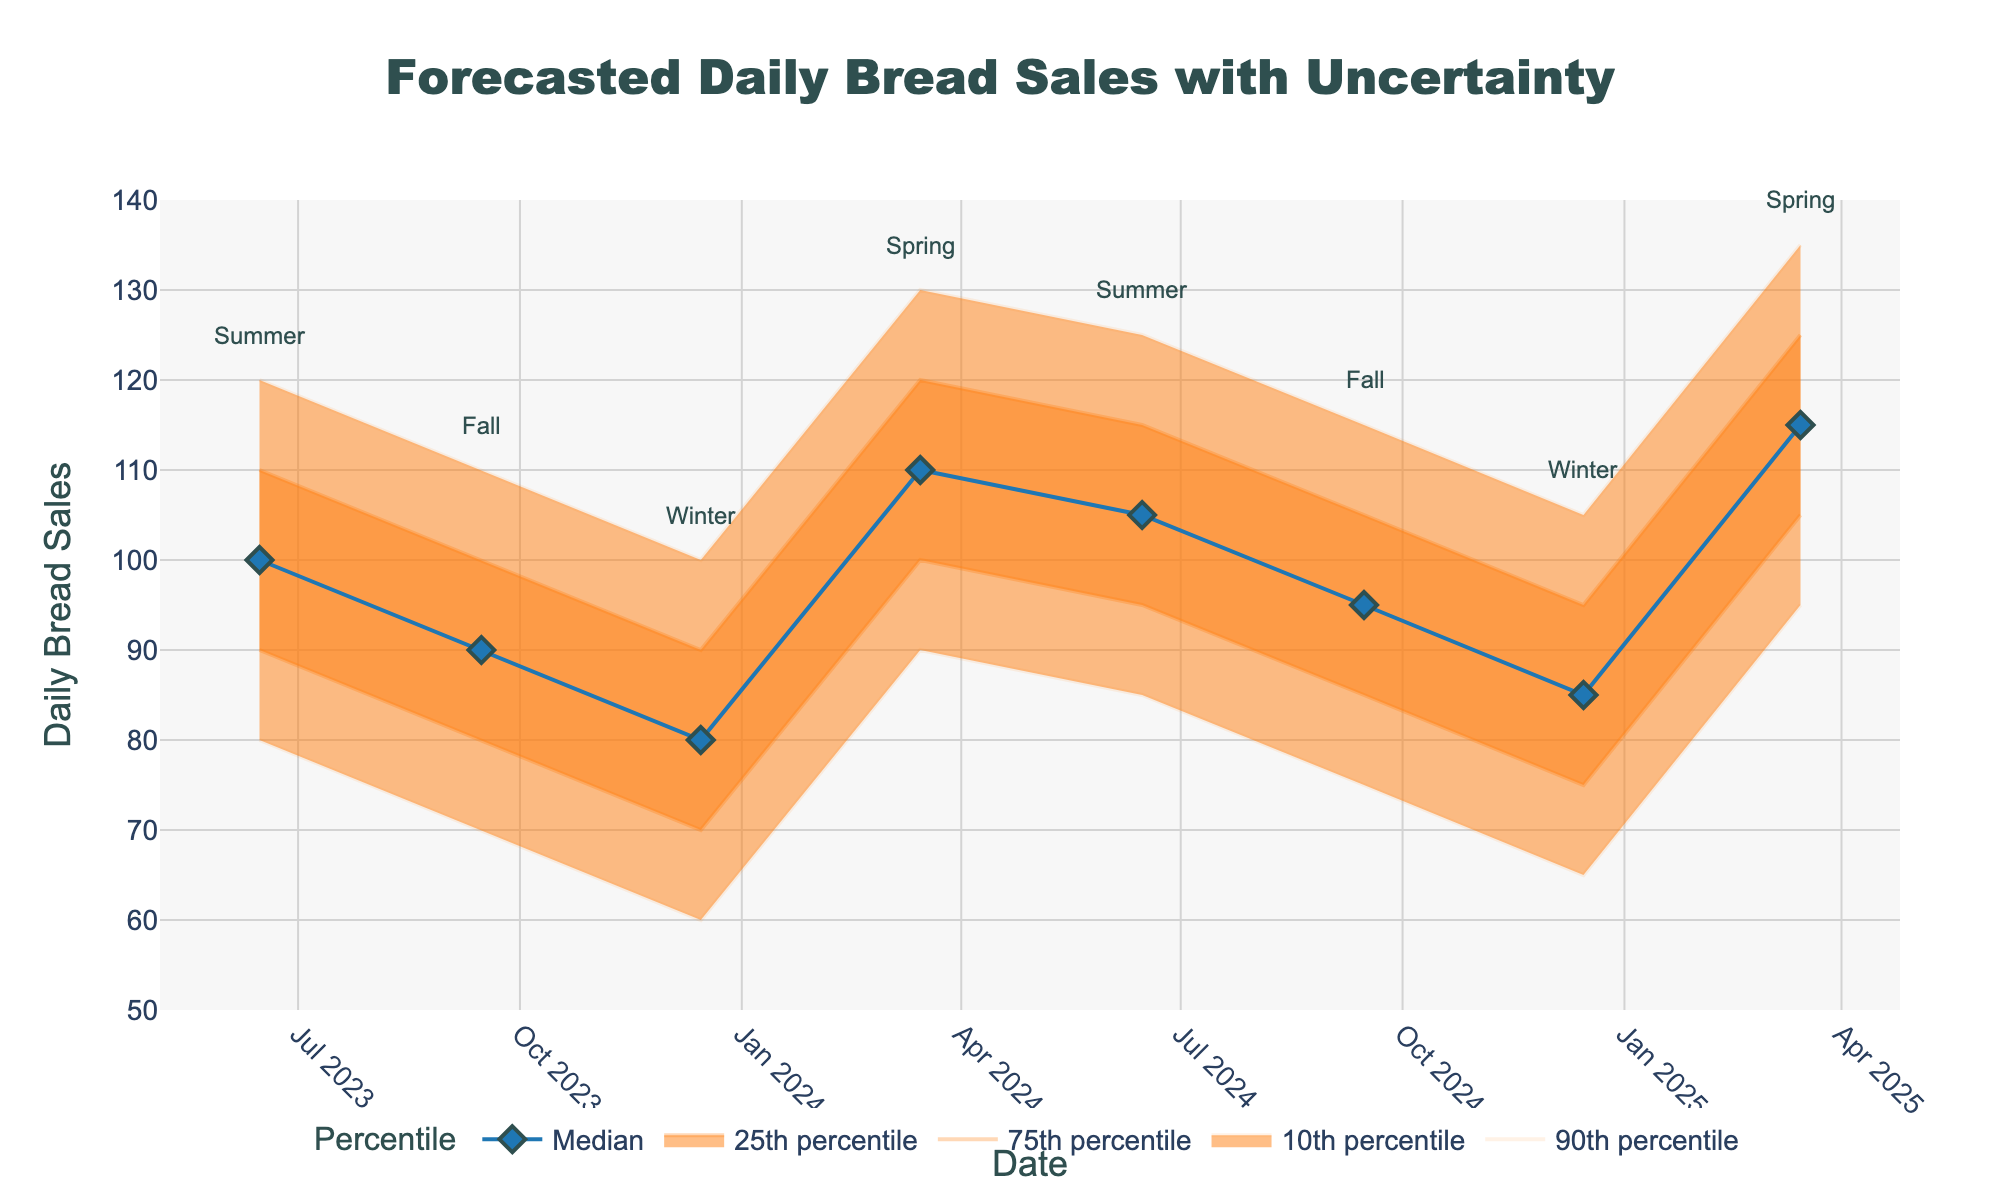what is the title of the chart? The title is displayed at the top of the chart and is large in size, indicating the main focus of the visualization.
Answer: Forecasted Daily Bread Sales with Uncertainty What does the x-axis represent? The x-axis is labeled and indicates the variable plotted along it. It spans multiple time points.
Answer: Date What is the median predicted daily bread sales for Winter 2024? The median value is represented by the blue line with markers, and we need to look at the value for Winter 2024. Referring to the given data, the median value for Winter 2024 (December 15, 2024) is 85.
Answer: 85 How do the median sales projections for Summer 2024 compare to those for Fall 2024? We need to locate the median sales projections for both Summer 2024 and Fall 2024 and compare them. Summer 2024 has a median of 105, while Fall 2024 has a median of 95.
Answer: Summer 2024 has higher median sales projections than Fall 2024 What is the range of the 90th percentile in Spring 2025? The 90th percentile range is given by the values at the Upper_90 and Lower_10 points for Spring 2025 (March 15, 2025). The Upper_90 value is 135 and the Lower_10 value is 95.
Answer: The range is 40 How does the uncertainty in Winter 2023 compare to that in Spring 2024? Uncertainty can be evaluated by the spread between the Upper_90 and Lower_10 values. For Winter 2023 (December 15, 2023), the spread is 100 - 60 = 40. For Spring 2024 (March 15, 2024), the spread is 130 - 90 = 40.
Answer: The uncertainties are the same What color is used to represent the 75th percentile range? The 75th percentile range is represented in the fan chart by a transparent color. It is a blend of colors used in between the 90th and median lines.
Answer: Light orange (medium transparency) Which season has the lowest median sales prediction in the entire forecast? Identify all the median values and find the lowest one through comparison. According to the data, Winter 2023 has the lowest median value of 80.
Answer: Winter 2023 What is the general trend of the median sales predictions from Summer 2023 to Spring 2025? Observing the blue line representing the median values from Summer 2023 to Spring 2025 indicates how the sales change over time. There is a rising trend where median sales increase from 100 in Summer 2023 to 115 in Spring 2025.
Answer: Median predictions show a rising trend How does the uncertainty range (10th to 90th percentile) change from Fall 2023 to Fall 2024? Compare the spread between the Upper_90 and Lower_10 values for Fall 2023 and Fall 2024. Fall 2023's spread is 100 - 70 = 30 and Fall 2024's spread is 115 - 75 = 40.
Answer: The uncertainty range increases from 30 to 40 